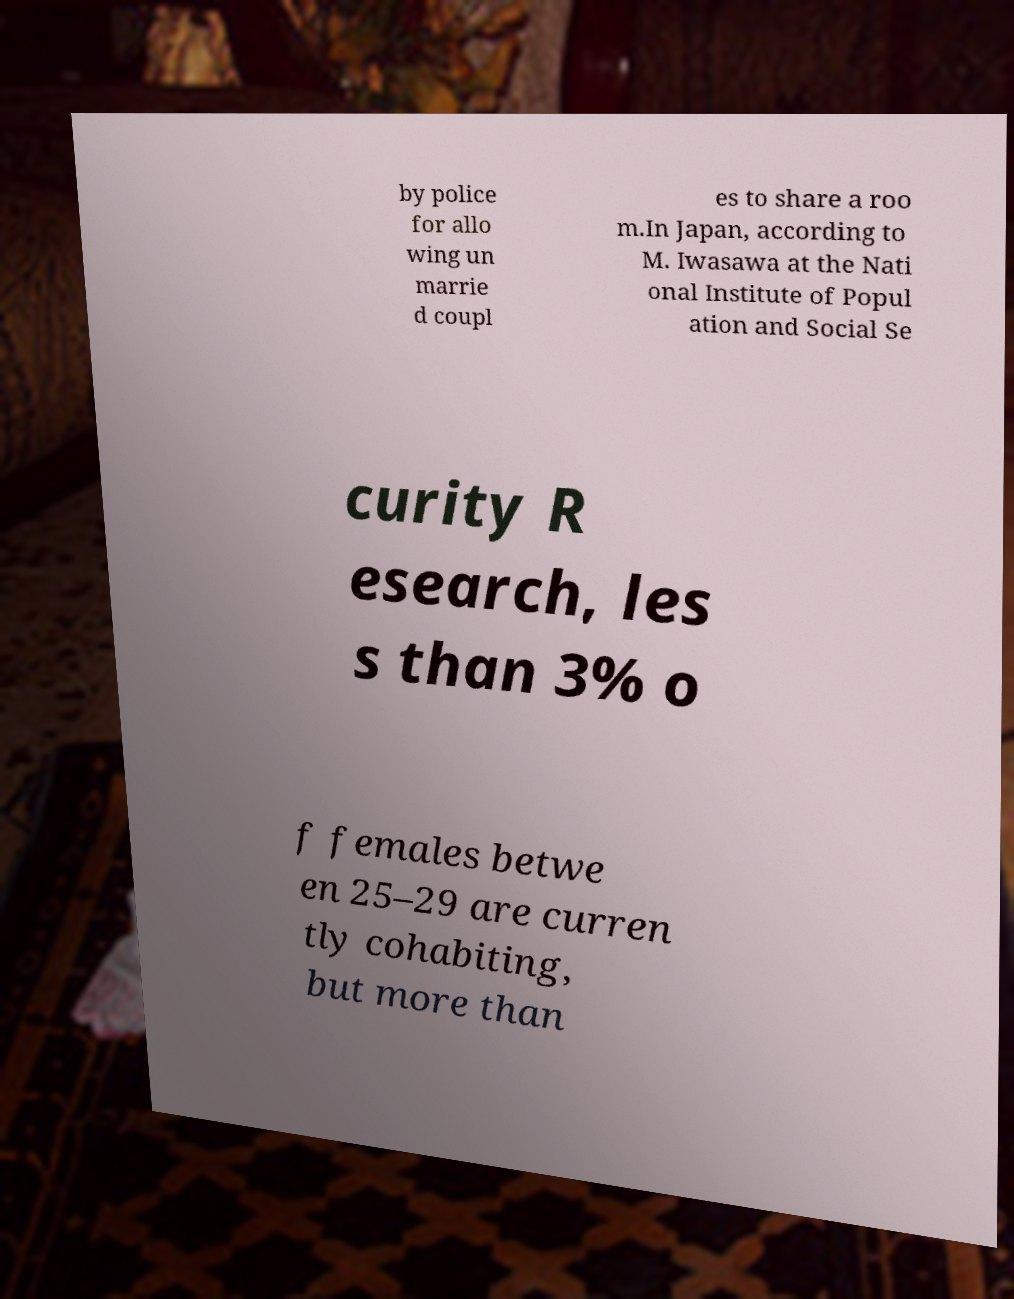Can you read and provide the text displayed in the image?This photo seems to have some interesting text. Can you extract and type it out for me? by police for allo wing un marrie d coupl es to share a roo m.In Japan, according to M. Iwasawa at the Nati onal Institute of Popul ation and Social Se curity R esearch, les s than 3% o f females betwe en 25–29 are curren tly cohabiting, but more than 